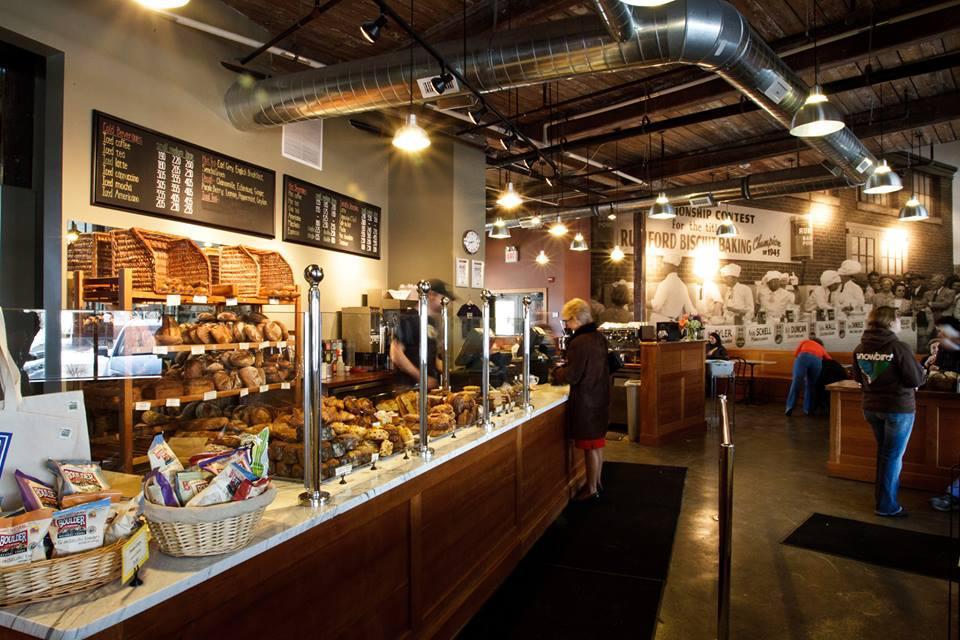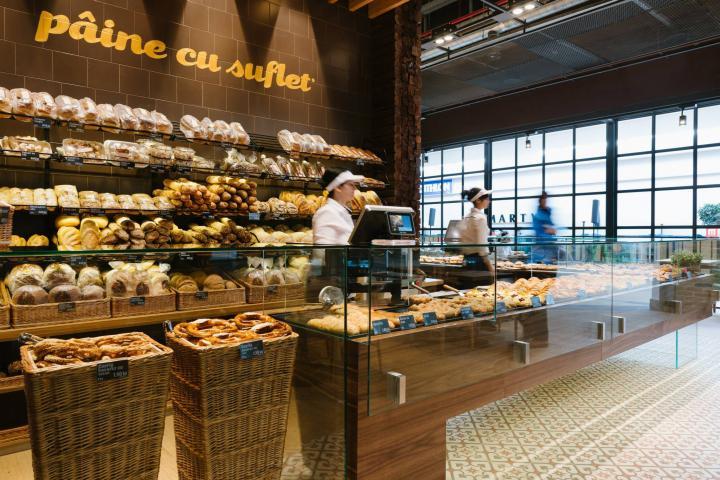The first image is the image on the left, the second image is the image on the right. Considering the images on both sides, is "there is exactly one person in the image on the right." valid? Answer yes or no. No. 